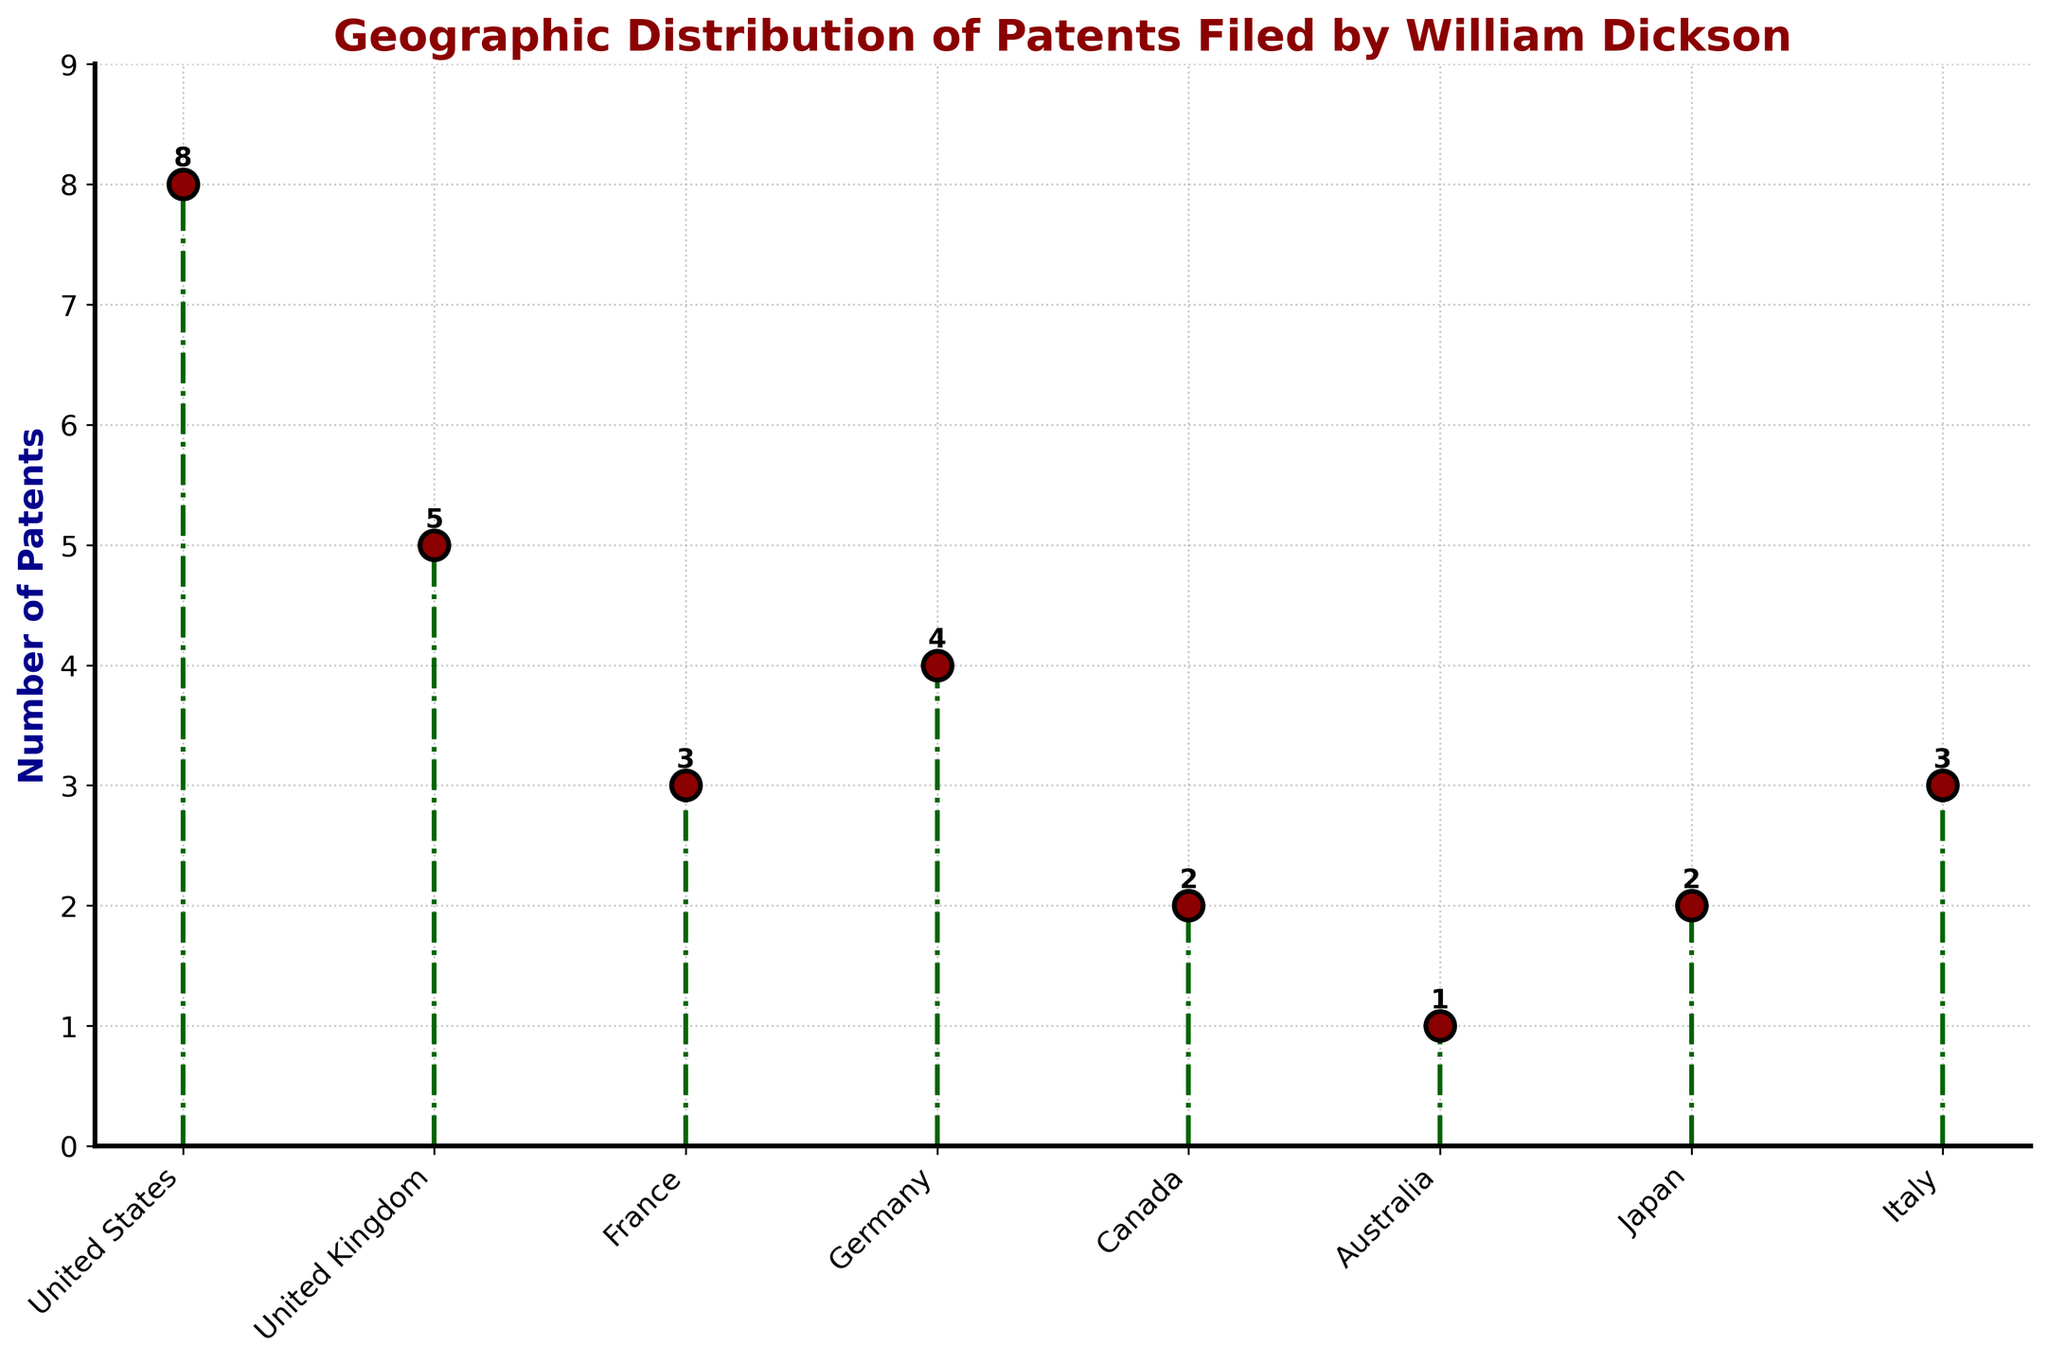What's the title of the figure? The title of a figure is usually at the top and summarizes the content. Here, the title is "Geographic Distribution of Patents Filed by William Dickson."
Answer: Geographic Distribution of Patents Filed by William Dickson How many patents were filed in Germany? Locate "Germany" on the x-axis and trace upwards to the corresponding point on the stem. The data label next to the marker indicates the number of patents as 4.
Answer: 4 Which country has the most patents filed by William Dickson? Identify the highest marker on the plot. The United States has the highest marker at 8 patents.
Answer: United States What's the total number of patents filed by William Dickson in all countries combined? Sum the values of all data points: 8 (US) + 5 (UK) + 3 (France) + 4 (Germany) + 2 (Canada) + 1 (Australia) + 2 (Japan) + 3 (Italy). The total is 28.
Answer: 28 What is the average number of patents filed per country? The total number of patents is 28 across 8 countries. Divide 28 by 8 to get the average. 28 / 8 = 3.5
Answer: 3.5 What's the second highest number of patents filed in a country? Identify the two highest values. The United States has 8 patents (highest), and the United Kingdom has 5 patents (second highest).
Answer: 5 How many countries have more than 3 patents filed? Identify the countries with more than 3 patents: United States (8), United Kingdom (5), Germany (4). Three countries meet this criterion.
Answer: 3 Is the number of patents filed in Italy equal to the number filed in France? Compare the values for Italy and France. Both have 3 patents each.
Answer: Yes Are there any countries where only one patent was filed by William Dickson? Look for a marker with the value 1. Australia has only one patent filed.
Answer: Yes What's the difference in the number of patents filed between Japan and Canada? Find Japan with 2 patents and Canada with 2 patents. The difference is 2 - 2 = 0.
Answer: 0 